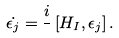<formula> <loc_0><loc_0><loc_500><loc_500>\dot { \epsilon _ { j } } = \frac { i } { } \left [ H _ { I } , \epsilon _ { j } \right ] .</formula> 